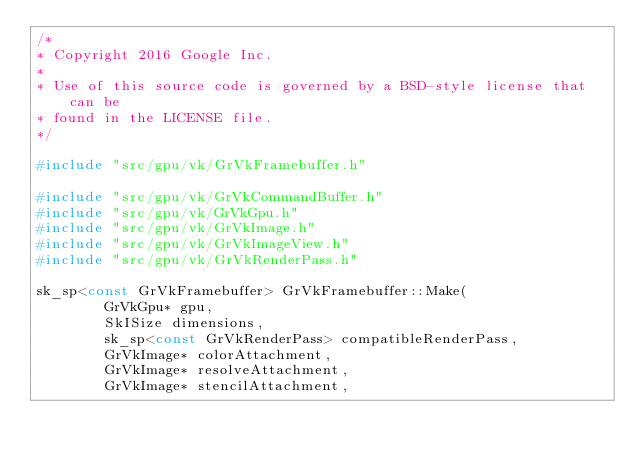<code> <loc_0><loc_0><loc_500><loc_500><_C++_>/*
* Copyright 2016 Google Inc.
*
* Use of this source code is governed by a BSD-style license that can be
* found in the LICENSE file.
*/

#include "src/gpu/vk/GrVkFramebuffer.h"

#include "src/gpu/vk/GrVkCommandBuffer.h"
#include "src/gpu/vk/GrVkGpu.h"
#include "src/gpu/vk/GrVkImage.h"
#include "src/gpu/vk/GrVkImageView.h"
#include "src/gpu/vk/GrVkRenderPass.h"

sk_sp<const GrVkFramebuffer> GrVkFramebuffer::Make(
        GrVkGpu* gpu,
        SkISize dimensions,
        sk_sp<const GrVkRenderPass> compatibleRenderPass,
        GrVkImage* colorAttachment,
        GrVkImage* resolveAttachment,
        GrVkImage* stencilAttachment,</code> 